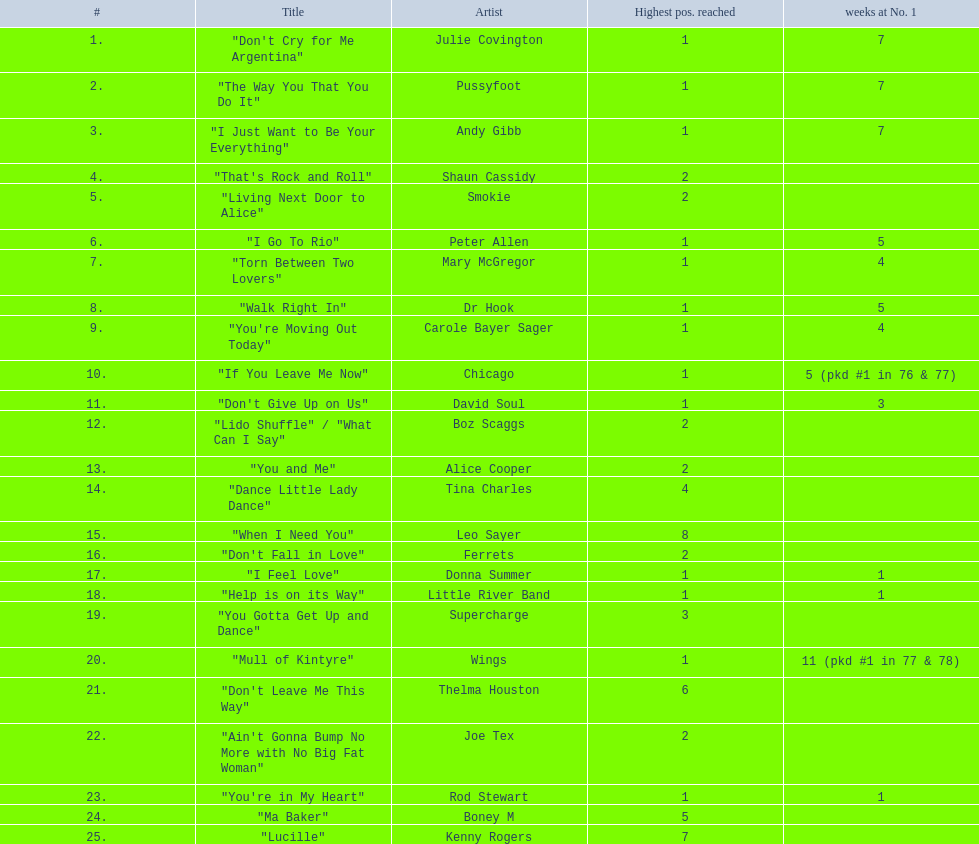Who had the one of the least weeks at number one? Rod Stewart. Who had no week at number one? Shaun Cassidy. Who had the highest number of weeks at number one? Wings. 